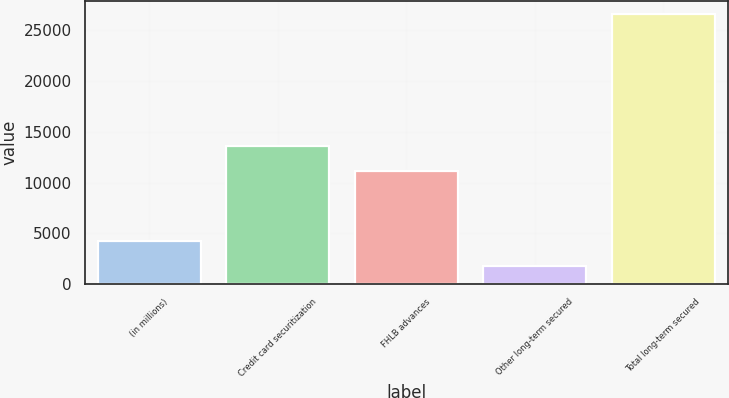Convert chart to OTSL. <chart><loc_0><loc_0><loc_500><loc_500><bar_chart><fcel>(in millions)<fcel>Credit card securitization<fcel>FHLB advances<fcel>Other long-term secured<fcel>Total long-term secured<nl><fcel>4264.8<fcel>13603.8<fcel>11124<fcel>1785<fcel>26583<nl></chart> 